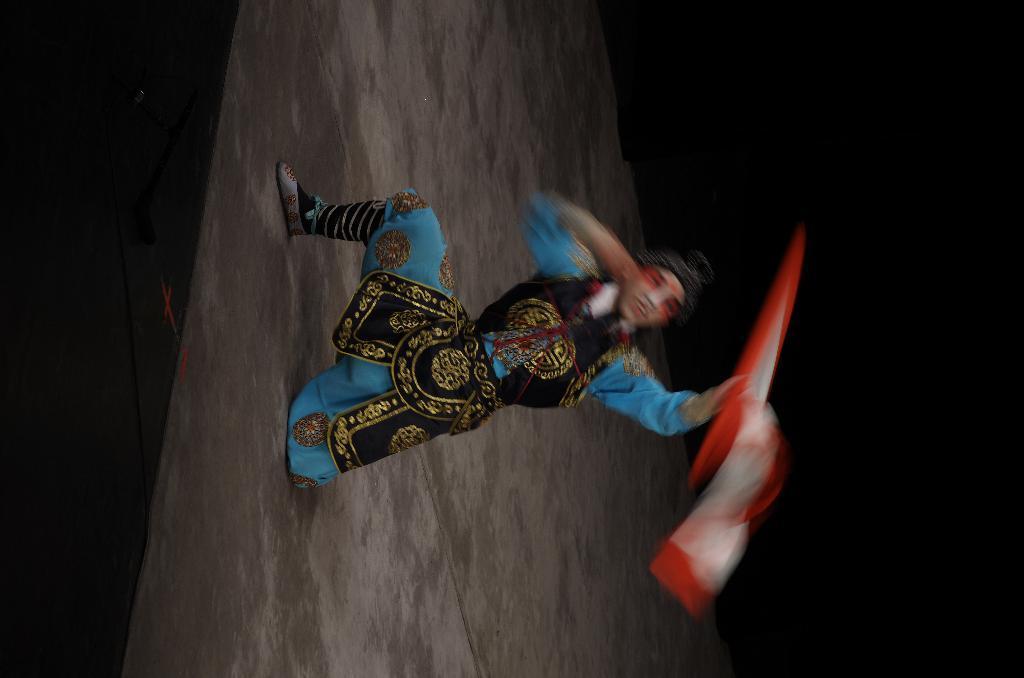Describe this image in one or two sentences. There is a person in blue and brown color combination, smiling and holding a cloth with one hand and kneeling down with one leg on the stage. And the background is dark in color. 